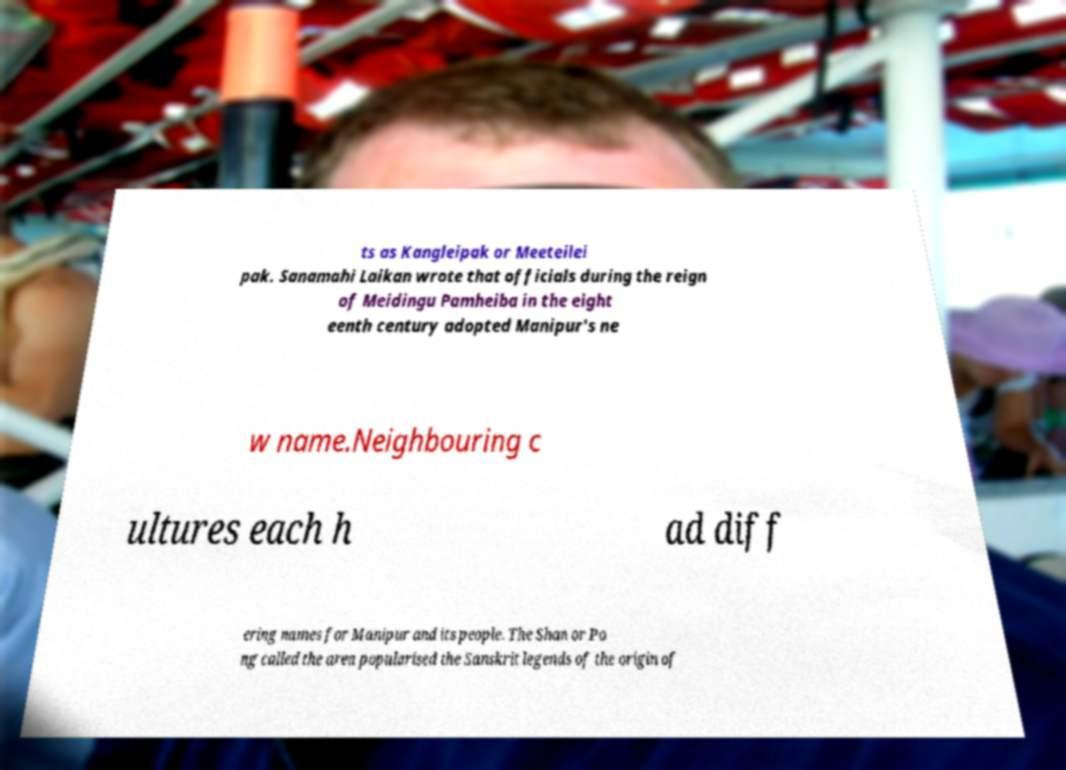There's text embedded in this image that I need extracted. Can you transcribe it verbatim? ts as Kangleipak or Meeteilei pak. Sanamahi Laikan wrote that officials during the reign of Meidingu Pamheiba in the eight eenth century adopted Manipur's ne w name.Neighbouring c ultures each h ad diff ering names for Manipur and its people. The Shan or Po ng called the area popularised the Sanskrit legends of the origin of 